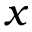Convert formula to latex. <formula><loc_0><loc_0><loc_500><loc_500>x</formula> 